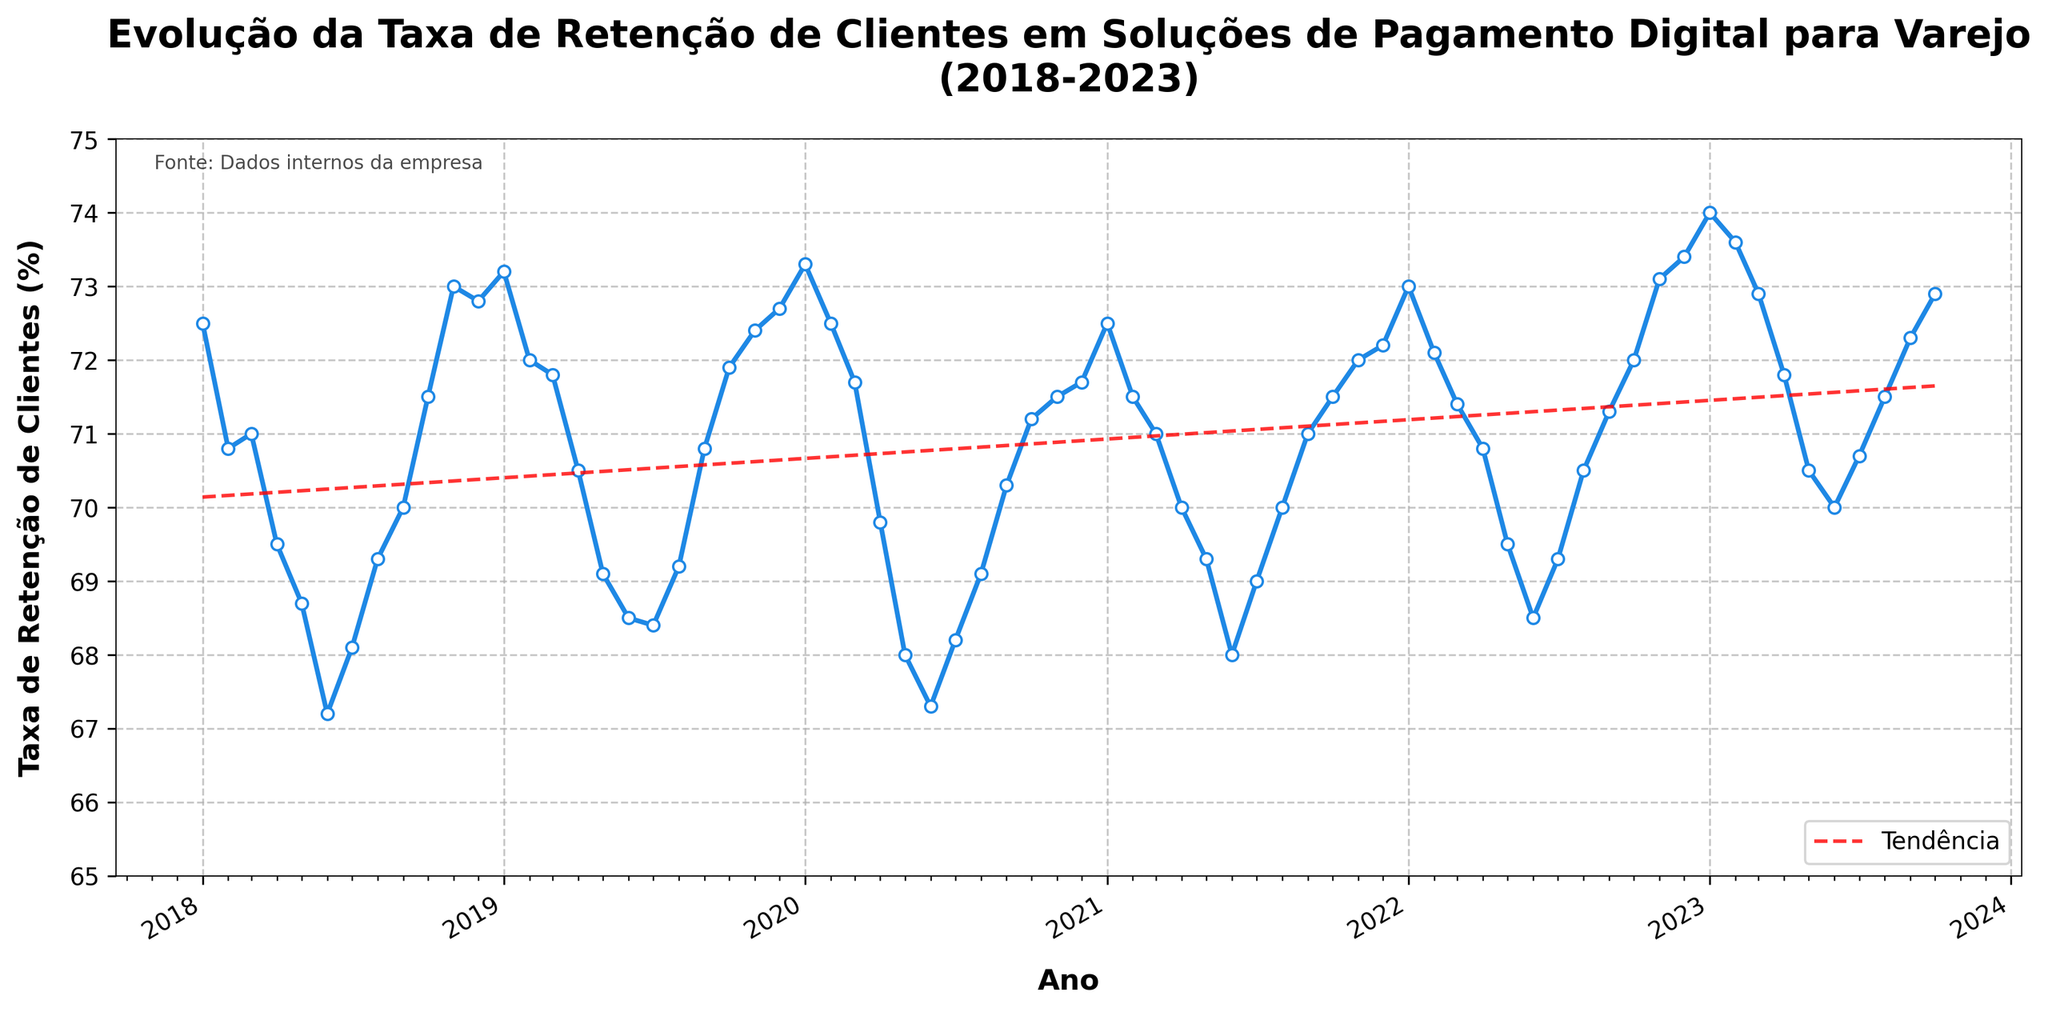What is the title of the plot? The title of the plot is usually located at the top center of the figure and helps in understanding what the plot is about. By looking at the title in this plot, "Evolução da Taxa de Retenção de Clientes em Soluções de Pagamento Digital para Varejo\n(2018-2023)", we can understand that it shows the evolution of customer retention rates for digital payment solutions in retail over the years 2018 to 2023.
Answer: Evolução da Taxa de Retenção de Clientes em Soluções de Pagamento Digital para Varejo (2018-2023) What does the y-axis represent? The label on the y-axis informs about the data it is representing. In this case, the label "Taxa de Retenção de Clientes (%)" indicates that the y-axis represents customer retention rates in percentages.
Answer: Customer retention rates in percentages Between which years is the data plotted? By looking at the x-axis of the plot, which is labeled with years, we can see that the timeline starts at 2018 and ends at 2023.
Answer: 2018 to 2023 What was the highest customer retention rate, and when did it occur? By observing the highest point on the curve, we can determine the maximum retention rate. The point corresponding to January 2023 stands out as the highest. According to the data, this point marks a retention rate of 74.0%.
Answer: 74.0% in January 2023 How does the trend line behave over the years? The red dashed line in the plot represents the trend line. Observing its general direction from left to right, we can see that it rises slightly, indicating that, on average, the customer retention rates have seen a slight upward trend over the years.
Answer: Slight upward trend Which month and year showed the lowest customer retention rate? By locating the lowest point on the plot, it corresponds to June 2020. According to the data, the retention rate at this point is 67.2%.
Answer: June 2020 Is there a significant difference in retention rates between December 2022 and January 2023? Comparing the data points for December 2022 (73.4%) and January 2023 (74.0%), we can observe that there is a slight increase of 0.6 percentage points.
Answer: 0.6% increase How did the customer retention rate change from January 2018 to January 2023? The plot starts at January 2018 with a retention rate of 72.5% and ends at January 2023 with a rate of 74.0%. By subtracting the former from the latter, we get an increase of 1.5 percentage points over this period.
Answer: Increased by 1.5% What was the average customer retention rate in 2019? To find the average retention rate for the year 2019, sum up the monthly retention rates and divide by 12. The rates are: 73.2, 72.0, 71.8, 70.5, 69.1, 68.5, 68.4, 69.2, 70.8, 71.9, 72.4, 72.7. Sum these to get 870.5, then divide by 12 to get approximately 72.54%.
Answer: 72.54% Which year experienced the most fluctuation in customer retention rates? By examining the variability in the plot's curve, we can identify the year with the most significant up-and-down movements. Observing the years, 2020 stands out with notable rises and falls, ranging from 67.2% in June to 73.3% in January.
Answer: 2020 